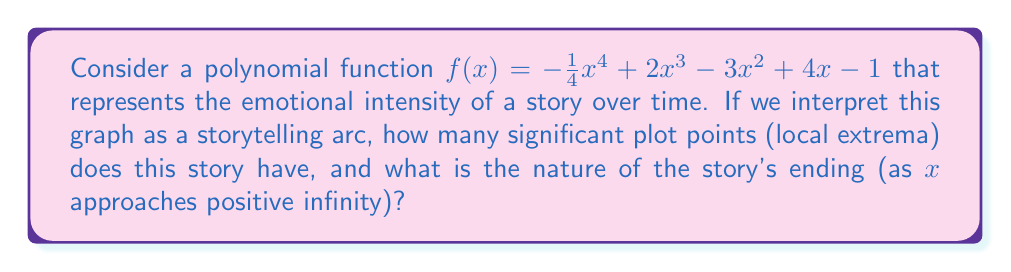Help me with this question. To analyze this polynomial graph and determine the storytelling arc, we need to follow these steps:

1) First, we need to find the critical points of the function. These are where the derivative equals zero or is undefined. The derivative is:

   $f'(x) = -x^3 + 6x^2 - 6x + 4$

2) To find the critical points, we set $f'(x) = 0$:

   $-x^3 + 6x^2 - 6x + 4 = 0$

   This cubic equation is difficult to solve by hand, but we can deduce that it will have either 1 or 3 real roots.

3) The second derivative is:

   $f''(x) = -3x^2 + 12x - 6$

4) The discriminant of $f''(x)$ is positive $(12^2 - 4(-3)(-6) = 144 - 72 = 72 > 0)$, which means $f''(x)$ has two real roots. This implies that $f'(x)$ has two turning points.

5) Given that $f'(x)$ has two turning points and approaches negative infinity as $x$ approaches positive infinity (due to the negative leading coefficient), we can conclude that $f'(x)$ must cross the x-axis three times.

6) These three roots of $f'(x)$ correspond to two local maxima and one local minimum of $f(x)$. These are our significant plot points.

7) As for the ending, we need to consider the behavior of $f(x)$ as $x$ approaches positive infinity. The leading term is $-\frac{1}{4}x^4$, which approaches negative infinity as $x$ increases. This indicates a downturn in the story's emotional intensity at the end.

Thus, the story has 3 significant plot points (two peaks and one valley in emotional intensity) and ends with decreasing emotional intensity.
Answer: 3 plot points; ending with decreasing intensity 